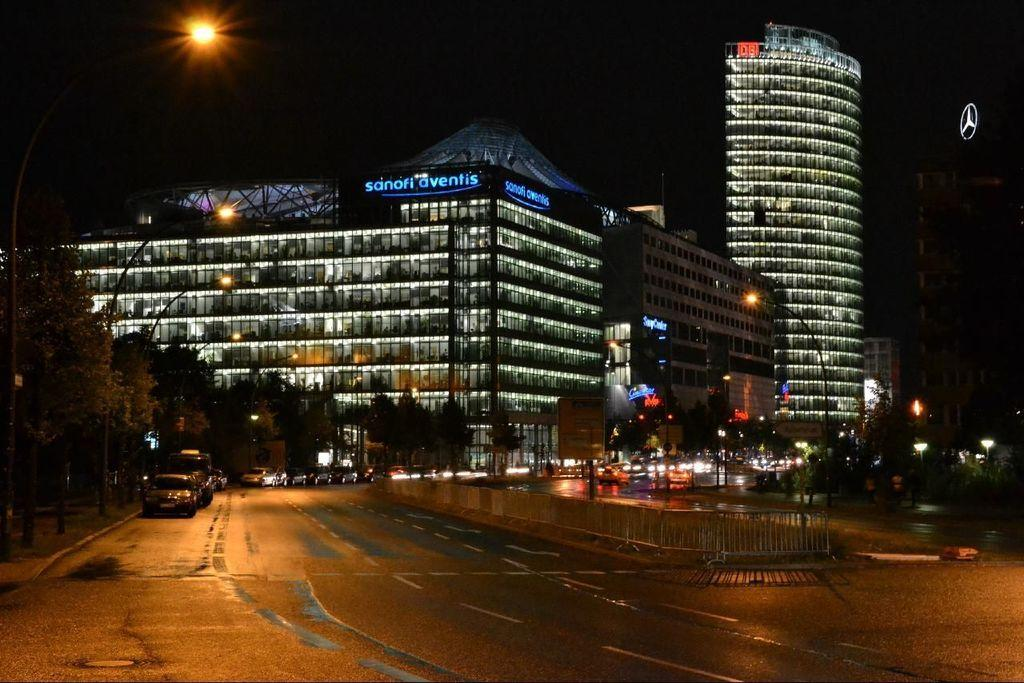What can be seen on the road in the image? There are vehicles on the road in the image. What objects are present alongside the road? There are poles and lights in the image. What structures are visible in the image? There are barricades, buildings, and trees in the image. How would you describe the lighting conditions in the image? The background of the image is dark. What type of cheese is being used to create fear in the image? There is no cheese or fear present in the image; it features vehicles, poles, lights, barricades, buildings, trees, and a dark background. What effect does the cheese have on the people in the image? There is no cheese or people present in the image, so it is not possible to determine any effects. 